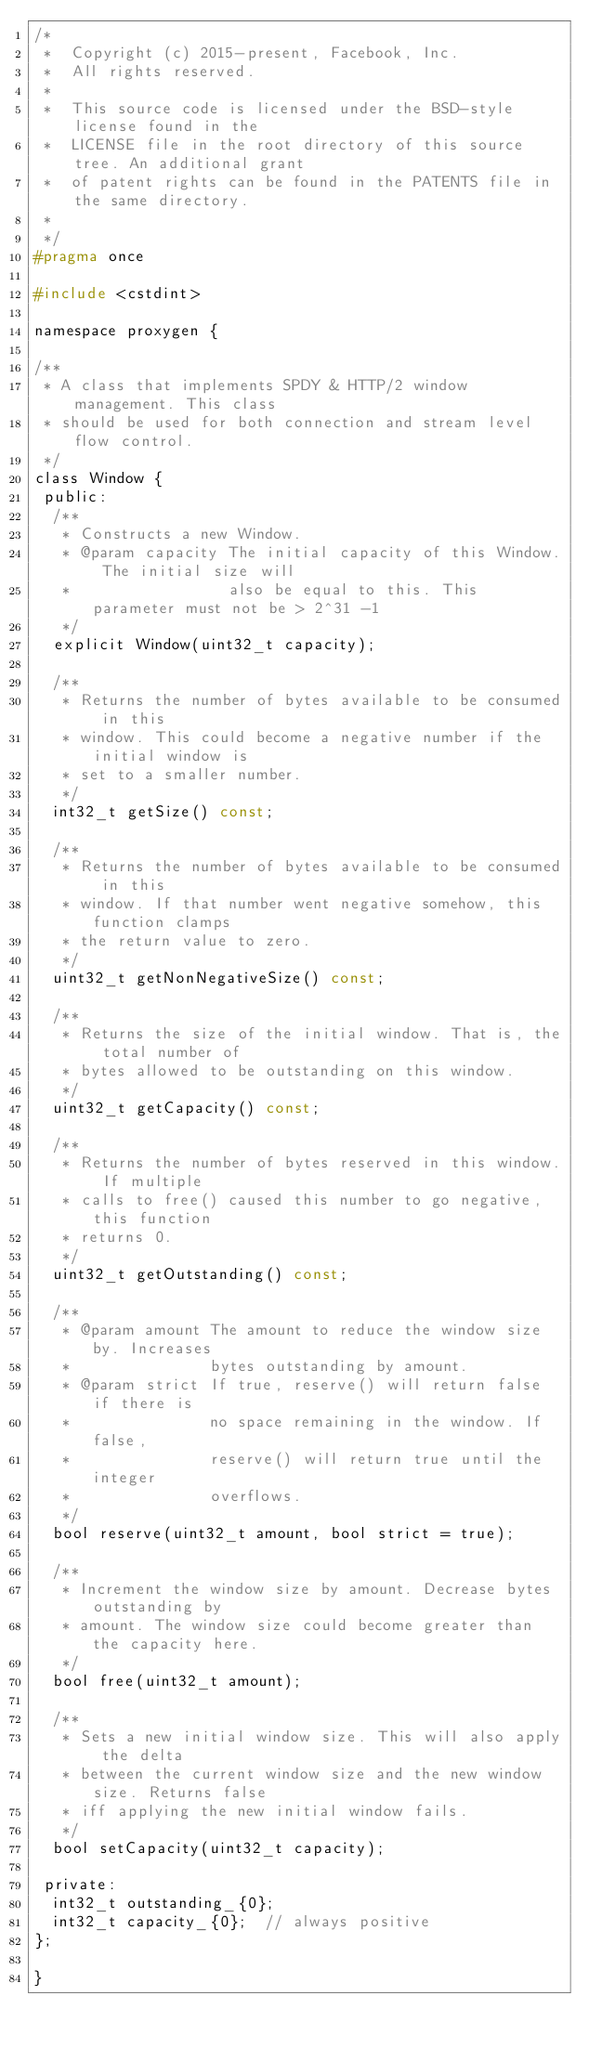<code> <loc_0><loc_0><loc_500><loc_500><_C_>/*
 *  Copyright (c) 2015-present, Facebook, Inc.
 *  All rights reserved.
 *
 *  This source code is licensed under the BSD-style license found in the
 *  LICENSE file in the root directory of this source tree. An additional grant
 *  of patent rights can be found in the PATENTS file in the same directory.
 *
 */
#pragma once

#include <cstdint>

namespace proxygen {

/**
 * A class that implements SPDY & HTTP/2 window management. This class
 * should be used for both connection and stream level flow control.
 */
class Window {
 public:
  /**
   * Constructs a new Window.
   * @param capacity The initial capacity of this Window. The initial size will
   *                 also be equal to this. This parameter must not be > 2^31 -1
   */
  explicit Window(uint32_t capacity);

  /**
   * Returns the number of bytes available to be consumed in this
   * window. This could become a negative number if the initial window is
   * set to a smaller number.
   */
  int32_t getSize() const;

  /**
   * Returns the number of bytes available to be consumed in this
   * window. If that number went negative somehow, this function clamps
   * the return value to zero.
   */
  uint32_t getNonNegativeSize() const;

  /**
   * Returns the size of the initial window. That is, the total number of
   * bytes allowed to be outstanding on this window.
   */
  uint32_t getCapacity() const;

  /**
   * Returns the number of bytes reserved in this window. If multiple
   * calls to free() caused this number to go negative, this function
   * returns 0.
   */
  uint32_t getOutstanding() const;

  /**
   * @param amount The amount to reduce the window size by. Increases
   *               bytes outstanding by amount.
   * @param strict If true, reserve() will return false if there is
   *               no space remaining in the window. If false,
   *               reserve() will return true until the integer
   *               overflows.
   */
  bool reserve(uint32_t amount, bool strict = true);

  /**
   * Increment the window size by amount. Decrease bytes outstanding by
   * amount. The window size could become greater than the capacity here.
   */
  bool free(uint32_t amount);

  /**
   * Sets a new initial window size. This will also apply the delta
   * between the current window size and the new window size. Returns false
   * iff applying the new initial window fails.
   */
  bool setCapacity(uint32_t capacity);

 private:
  int32_t outstanding_{0};
  int32_t capacity_{0};  // always positive
};

}
</code> 